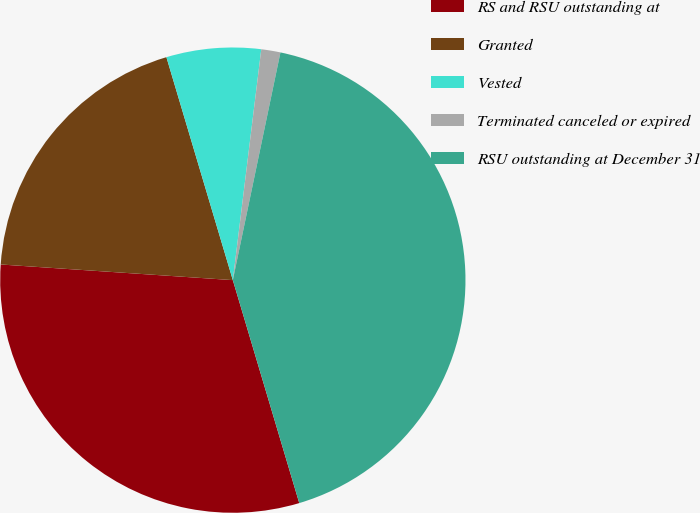<chart> <loc_0><loc_0><loc_500><loc_500><pie_chart><fcel>RS and RSU outstanding at<fcel>Granted<fcel>Vested<fcel>Terminated canceled or expired<fcel>RSU outstanding at December 31<nl><fcel>30.68%<fcel>19.32%<fcel>6.56%<fcel>1.33%<fcel>42.11%<nl></chart> 